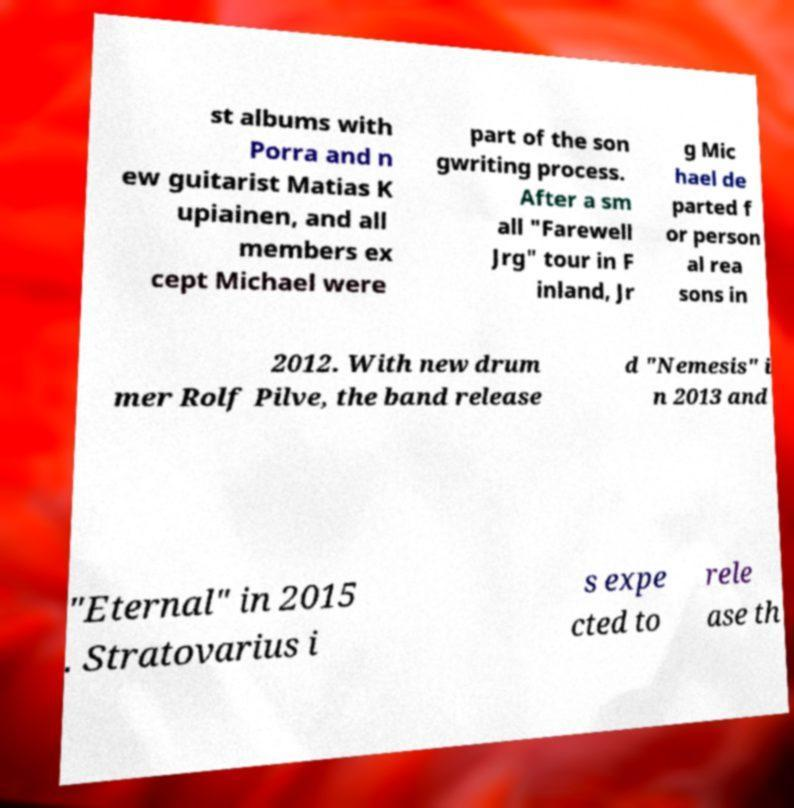Could you assist in decoding the text presented in this image and type it out clearly? st albums with Porra and n ew guitarist Matias K upiainen, and all members ex cept Michael were part of the son gwriting process. After a sm all "Farewell Jrg" tour in F inland, Jr g Mic hael de parted f or person al rea sons in 2012. With new drum mer Rolf Pilve, the band release d "Nemesis" i n 2013 and "Eternal" in 2015 . Stratovarius i s expe cted to rele ase th 